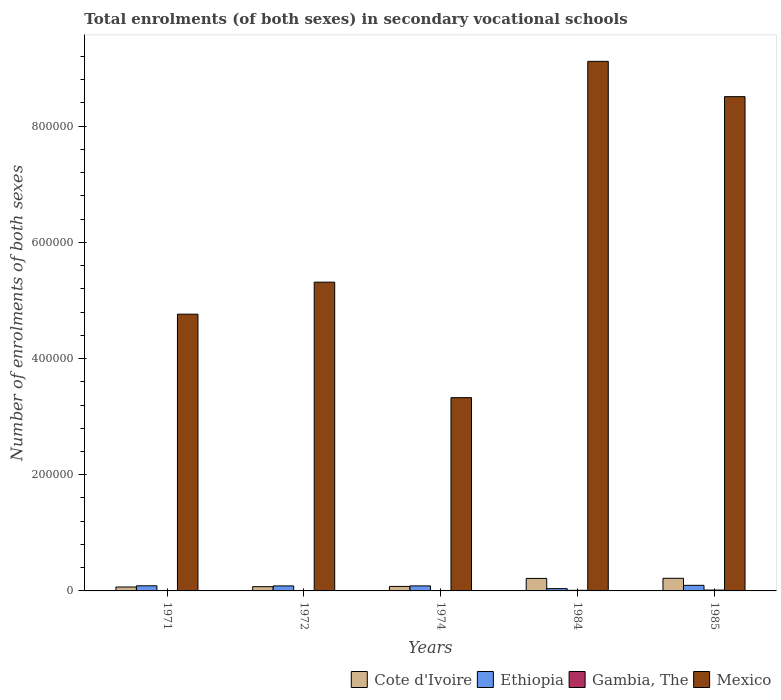Are the number of bars per tick equal to the number of legend labels?
Your answer should be very brief. Yes. Are the number of bars on each tick of the X-axis equal?
Ensure brevity in your answer.  Yes. How many bars are there on the 4th tick from the right?
Offer a terse response. 4. What is the label of the 1st group of bars from the left?
Offer a very short reply. 1971. In how many cases, is the number of bars for a given year not equal to the number of legend labels?
Make the answer very short. 0. What is the number of enrolments in secondary schools in Cote d'Ivoire in 1972?
Keep it short and to the point. 7297. Across all years, what is the maximum number of enrolments in secondary schools in Ethiopia?
Provide a succinct answer. 9618. Across all years, what is the minimum number of enrolments in secondary schools in Gambia, The?
Your answer should be compact. 330. In which year was the number of enrolments in secondary schools in Cote d'Ivoire minimum?
Offer a terse response. 1971. What is the total number of enrolments in secondary schools in Ethiopia in the graph?
Keep it short and to the point. 3.97e+04. What is the difference between the number of enrolments in secondary schools in Mexico in 1971 and that in 1974?
Ensure brevity in your answer.  1.44e+05. What is the difference between the number of enrolments in secondary schools in Mexico in 1985 and the number of enrolments in secondary schools in Cote d'Ivoire in 1984?
Offer a terse response. 8.29e+05. What is the average number of enrolments in secondary schools in Cote d'Ivoire per year?
Offer a very short reply. 1.30e+04. In the year 1974, what is the difference between the number of enrolments in secondary schools in Gambia, The and number of enrolments in secondary schools in Ethiopia?
Keep it short and to the point. -8276. What is the ratio of the number of enrolments in secondary schools in Ethiopia in 1974 to that in 1985?
Provide a succinct answer. 0.9. Is the difference between the number of enrolments in secondary schools in Gambia, The in 1971 and 1985 greater than the difference between the number of enrolments in secondary schools in Ethiopia in 1971 and 1985?
Ensure brevity in your answer.  No. What is the difference between the highest and the second highest number of enrolments in secondary schools in Ethiopia?
Your response must be concise. 796. What is the difference between the highest and the lowest number of enrolments in secondary schools in Gambia, The?
Ensure brevity in your answer.  1130. In how many years, is the number of enrolments in secondary schools in Ethiopia greater than the average number of enrolments in secondary schools in Ethiopia taken over all years?
Offer a terse response. 4. Is the sum of the number of enrolments in secondary schools in Ethiopia in 1984 and 1985 greater than the maximum number of enrolments in secondary schools in Gambia, The across all years?
Make the answer very short. Yes. What does the 2nd bar from the left in 1985 represents?
Your answer should be compact. Ethiopia. What does the 3rd bar from the right in 1974 represents?
Your response must be concise. Ethiopia. Is it the case that in every year, the sum of the number of enrolments in secondary schools in Gambia, The and number of enrolments in secondary schools in Ethiopia is greater than the number of enrolments in secondary schools in Mexico?
Ensure brevity in your answer.  No. Are all the bars in the graph horizontal?
Offer a very short reply. No. How many years are there in the graph?
Give a very brief answer. 5. How many legend labels are there?
Make the answer very short. 4. How are the legend labels stacked?
Ensure brevity in your answer.  Horizontal. What is the title of the graph?
Offer a terse response. Total enrolments (of both sexes) in secondary vocational schools. What is the label or title of the X-axis?
Provide a succinct answer. Years. What is the label or title of the Y-axis?
Keep it short and to the point. Number of enrolments of both sexes. What is the Number of enrolments of both sexes of Cote d'Ivoire in 1971?
Give a very brief answer. 6745. What is the Number of enrolments of both sexes in Ethiopia in 1971?
Your answer should be very brief. 8822. What is the Number of enrolments of both sexes in Gambia, The in 1971?
Provide a short and direct response. 330. What is the Number of enrolments of both sexes in Mexico in 1971?
Provide a succinct answer. 4.76e+05. What is the Number of enrolments of both sexes of Cote d'Ivoire in 1972?
Your answer should be compact. 7297. What is the Number of enrolments of both sexes of Ethiopia in 1972?
Provide a succinct answer. 8612. What is the Number of enrolments of both sexes in Gambia, The in 1972?
Ensure brevity in your answer.  376. What is the Number of enrolments of both sexes in Mexico in 1972?
Give a very brief answer. 5.32e+05. What is the Number of enrolments of both sexes in Cote d'Ivoire in 1974?
Make the answer very short. 7729. What is the Number of enrolments of both sexes in Ethiopia in 1974?
Your response must be concise. 8659. What is the Number of enrolments of both sexes of Gambia, The in 1974?
Keep it short and to the point. 383. What is the Number of enrolments of both sexes in Mexico in 1974?
Give a very brief answer. 3.33e+05. What is the Number of enrolments of both sexes in Cote d'Ivoire in 1984?
Your answer should be compact. 2.15e+04. What is the Number of enrolments of both sexes in Ethiopia in 1984?
Make the answer very short. 3949. What is the Number of enrolments of both sexes of Gambia, The in 1984?
Make the answer very short. 1040. What is the Number of enrolments of both sexes in Mexico in 1984?
Keep it short and to the point. 9.12e+05. What is the Number of enrolments of both sexes in Cote d'Ivoire in 1985?
Make the answer very short. 2.18e+04. What is the Number of enrolments of both sexes in Ethiopia in 1985?
Give a very brief answer. 9618. What is the Number of enrolments of both sexes of Gambia, The in 1985?
Give a very brief answer. 1460. What is the Number of enrolments of both sexes in Mexico in 1985?
Your answer should be compact. 8.51e+05. Across all years, what is the maximum Number of enrolments of both sexes of Cote d'Ivoire?
Provide a succinct answer. 2.18e+04. Across all years, what is the maximum Number of enrolments of both sexes of Ethiopia?
Make the answer very short. 9618. Across all years, what is the maximum Number of enrolments of both sexes of Gambia, The?
Your answer should be very brief. 1460. Across all years, what is the maximum Number of enrolments of both sexes of Mexico?
Provide a succinct answer. 9.12e+05. Across all years, what is the minimum Number of enrolments of both sexes in Cote d'Ivoire?
Your response must be concise. 6745. Across all years, what is the minimum Number of enrolments of both sexes in Ethiopia?
Your answer should be very brief. 3949. Across all years, what is the minimum Number of enrolments of both sexes of Gambia, The?
Offer a very short reply. 330. Across all years, what is the minimum Number of enrolments of both sexes of Mexico?
Ensure brevity in your answer.  3.33e+05. What is the total Number of enrolments of both sexes of Cote d'Ivoire in the graph?
Your response must be concise. 6.51e+04. What is the total Number of enrolments of both sexes of Ethiopia in the graph?
Your answer should be very brief. 3.97e+04. What is the total Number of enrolments of both sexes of Gambia, The in the graph?
Give a very brief answer. 3589. What is the total Number of enrolments of both sexes of Mexico in the graph?
Your answer should be very brief. 3.10e+06. What is the difference between the Number of enrolments of both sexes in Cote d'Ivoire in 1971 and that in 1972?
Offer a very short reply. -552. What is the difference between the Number of enrolments of both sexes of Ethiopia in 1971 and that in 1972?
Offer a terse response. 210. What is the difference between the Number of enrolments of both sexes of Gambia, The in 1971 and that in 1972?
Your answer should be compact. -46. What is the difference between the Number of enrolments of both sexes in Mexico in 1971 and that in 1972?
Offer a terse response. -5.51e+04. What is the difference between the Number of enrolments of both sexes of Cote d'Ivoire in 1971 and that in 1974?
Offer a terse response. -984. What is the difference between the Number of enrolments of both sexes of Ethiopia in 1971 and that in 1974?
Keep it short and to the point. 163. What is the difference between the Number of enrolments of both sexes of Gambia, The in 1971 and that in 1974?
Provide a short and direct response. -53. What is the difference between the Number of enrolments of both sexes in Mexico in 1971 and that in 1974?
Keep it short and to the point. 1.44e+05. What is the difference between the Number of enrolments of both sexes of Cote d'Ivoire in 1971 and that in 1984?
Provide a short and direct response. -1.48e+04. What is the difference between the Number of enrolments of both sexes in Ethiopia in 1971 and that in 1984?
Provide a short and direct response. 4873. What is the difference between the Number of enrolments of both sexes in Gambia, The in 1971 and that in 1984?
Your answer should be compact. -710. What is the difference between the Number of enrolments of both sexes of Mexico in 1971 and that in 1984?
Provide a short and direct response. -4.35e+05. What is the difference between the Number of enrolments of both sexes in Cote d'Ivoire in 1971 and that in 1985?
Your response must be concise. -1.50e+04. What is the difference between the Number of enrolments of both sexes in Ethiopia in 1971 and that in 1985?
Offer a terse response. -796. What is the difference between the Number of enrolments of both sexes of Gambia, The in 1971 and that in 1985?
Provide a succinct answer. -1130. What is the difference between the Number of enrolments of both sexes of Mexico in 1971 and that in 1985?
Give a very brief answer. -3.74e+05. What is the difference between the Number of enrolments of both sexes in Cote d'Ivoire in 1972 and that in 1974?
Provide a succinct answer. -432. What is the difference between the Number of enrolments of both sexes in Ethiopia in 1972 and that in 1974?
Offer a terse response. -47. What is the difference between the Number of enrolments of both sexes of Mexico in 1972 and that in 1974?
Offer a very short reply. 1.99e+05. What is the difference between the Number of enrolments of both sexes in Cote d'Ivoire in 1972 and that in 1984?
Provide a short and direct response. -1.42e+04. What is the difference between the Number of enrolments of both sexes of Ethiopia in 1972 and that in 1984?
Ensure brevity in your answer.  4663. What is the difference between the Number of enrolments of both sexes of Gambia, The in 1972 and that in 1984?
Offer a very short reply. -664. What is the difference between the Number of enrolments of both sexes of Mexico in 1972 and that in 1984?
Keep it short and to the point. -3.80e+05. What is the difference between the Number of enrolments of both sexes in Cote d'Ivoire in 1972 and that in 1985?
Offer a terse response. -1.45e+04. What is the difference between the Number of enrolments of both sexes of Ethiopia in 1972 and that in 1985?
Keep it short and to the point. -1006. What is the difference between the Number of enrolments of both sexes in Gambia, The in 1972 and that in 1985?
Offer a terse response. -1084. What is the difference between the Number of enrolments of both sexes in Mexico in 1972 and that in 1985?
Ensure brevity in your answer.  -3.19e+05. What is the difference between the Number of enrolments of both sexes of Cote d'Ivoire in 1974 and that in 1984?
Offer a terse response. -1.38e+04. What is the difference between the Number of enrolments of both sexes in Ethiopia in 1974 and that in 1984?
Your answer should be compact. 4710. What is the difference between the Number of enrolments of both sexes of Gambia, The in 1974 and that in 1984?
Provide a succinct answer. -657. What is the difference between the Number of enrolments of both sexes in Mexico in 1974 and that in 1984?
Ensure brevity in your answer.  -5.79e+05. What is the difference between the Number of enrolments of both sexes of Cote d'Ivoire in 1974 and that in 1985?
Provide a short and direct response. -1.40e+04. What is the difference between the Number of enrolments of both sexes of Ethiopia in 1974 and that in 1985?
Ensure brevity in your answer.  -959. What is the difference between the Number of enrolments of both sexes in Gambia, The in 1974 and that in 1985?
Offer a very short reply. -1077. What is the difference between the Number of enrolments of both sexes in Mexico in 1974 and that in 1985?
Keep it short and to the point. -5.18e+05. What is the difference between the Number of enrolments of both sexes of Cote d'Ivoire in 1984 and that in 1985?
Give a very brief answer. -213. What is the difference between the Number of enrolments of both sexes of Ethiopia in 1984 and that in 1985?
Provide a short and direct response. -5669. What is the difference between the Number of enrolments of both sexes of Gambia, The in 1984 and that in 1985?
Provide a succinct answer. -420. What is the difference between the Number of enrolments of both sexes in Mexico in 1984 and that in 1985?
Provide a succinct answer. 6.08e+04. What is the difference between the Number of enrolments of both sexes of Cote d'Ivoire in 1971 and the Number of enrolments of both sexes of Ethiopia in 1972?
Provide a short and direct response. -1867. What is the difference between the Number of enrolments of both sexes in Cote d'Ivoire in 1971 and the Number of enrolments of both sexes in Gambia, The in 1972?
Your response must be concise. 6369. What is the difference between the Number of enrolments of both sexes in Cote d'Ivoire in 1971 and the Number of enrolments of both sexes in Mexico in 1972?
Offer a very short reply. -5.25e+05. What is the difference between the Number of enrolments of both sexes in Ethiopia in 1971 and the Number of enrolments of both sexes in Gambia, The in 1972?
Offer a terse response. 8446. What is the difference between the Number of enrolments of both sexes in Ethiopia in 1971 and the Number of enrolments of both sexes in Mexico in 1972?
Make the answer very short. -5.23e+05. What is the difference between the Number of enrolments of both sexes in Gambia, The in 1971 and the Number of enrolments of both sexes in Mexico in 1972?
Ensure brevity in your answer.  -5.31e+05. What is the difference between the Number of enrolments of both sexes in Cote d'Ivoire in 1971 and the Number of enrolments of both sexes in Ethiopia in 1974?
Offer a very short reply. -1914. What is the difference between the Number of enrolments of both sexes in Cote d'Ivoire in 1971 and the Number of enrolments of both sexes in Gambia, The in 1974?
Make the answer very short. 6362. What is the difference between the Number of enrolments of both sexes of Cote d'Ivoire in 1971 and the Number of enrolments of both sexes of Mexico in 1974?
Your response must be concise. -3.26e+05. What is the difference between the Number of enrolments of both sexes of Ethiopia in 1971 and the Number of enrolments of both sexes of Gambia, The in 1974?
Make the answer very short. 8439. What is the difference between the Number of enrolments of both sexes of Ethiopia in 1971 and the Number of enrolments of both sexes of Mexico in 1974?
Ensure brevity in your answer.  -3.24e+05. What is the difference between the Number of enrolments of both sexes in Gambia, The in 1971 and the Number of enrolments of both sexes in Mexico in 1974?
Provide a succinct answer. -3.32e+05. What is the difference between the Number of enrolments of both sexes of Cote d'Ivoire in 1971 and the Number of enrolments of both sexes of Ethiopia in 1984?
Provide a short and direct response. 2796. What is the difference between the Number of enrolments of both sexes of Cote d'Ivoire in 1971 and the Number of enrolments of both sexes of Gambia, The in 1984?
Offer a terse response. 5705. What is the difference between the Number of enrolments of both sexes in Cote d'Ivoire in 1971 and the Number of enrolments of both sexes in Mexico in 1984?
Offer a terse response. -9.05e+05. What is the difference between the Number of enrolments of both sexes in Ethiopia in 1971 and the Number of enrolments of both sexes in Gambia, The in 1984?
Ensure brevity in your answer.  7782. What is the difference between the Number of enrolments of both sexes of Ethiopia in 1971 and the Number of enrolments of both sexes of Mexico in 1984?
Give a very brief answer. -9.03e+05. What is the difference between the Number of enrolments of both sexes in Gambia, The in 1971 and the Number of enrolments of both sexes in Mexico in 1984?
Give a very brief answer. -9.11e+05. What is the difference between the Number of enrolments of both sexes of Cote d'Ivoire in 1971 and the Number of enrolments of both sexes of Ethiopia in 1985?
Your response must be concise. -2873. What is the difference between the Number of enrolments of both sexes of Cote d'Ivoire in 1971 and the Number of enrolments of both sexes of Gambia, The in 1985?
Make the answer very short. 5285. What is the difference between the Number of enrolments of both sexes in Cote d'Ivoire in 1971 and the Number of enrolments of both sexes in Mexico in 1985?
Keep it short and to the point. -8.44e+05. What is the difference between the Number of enrolments of both sexes of Ethiopia in 1971 and the Number of enrolments of both sexes of Gambia, The in 1985?
Your answer should be very brief. 7362. What is the difference between the Number of enrolments of both sexes of Ethiopia in 1971 and the Number of enrolments of both sexes of Mexico in 1985?
Provide a short and direct response. -8.42e+05. What is the difference between the Number of enrolments of both sexes in Gambia, The in 1971 and the Number of enrolments of both sexes in Mexico in 1985?
Offer a very short reply. -8.51e+05. What is the difference between the Number of enrolments of both sexes of Cote d'Ivoire in 1972 and the Number of enrolments of both sexes of Ethiopia in 1974?
Keep it short and to the point. -1362. What is the difference between the Number of enrolments of both sexes in Cote d'Ivoire in 1972 and the Number of enrolments of both sexes in Gambia, The in 1974?
Keep it short and to the point. 6914. What is the difference between the Number of enrolments of both sexes in Cote d'Ivoire in 1972 and the Number of enrolments of both sexes in Mexico in 1974?
Offer a terse response. -3.25e+05. What is the difference between the Number of enrolments of both sexes of Ethiopia in 1972 and the Number of enrolments of both sexes of Gambia, The in 1974?
Provide a short and direct response. 8229. What is the difference between the Number of enrolments of both sexes of Ethiopia in 1972 and the Number of enrolments of both sexes of Mexico in 1974?
Your answer should be compact. -3.24e+05. What is the difference between the Number of enrolments of both sexes of Gambia, The in 1972 and the Number of enrolments of both sexes of Mexico in 1974?
Offer a very short reply. -3.32e+05. What is the difference between the Number of enrolments of both sexes in Cote d'Ivoire in 1972 and the Number of enrolments of both sexes in Ethiopia in 1984?
Offer a very short reply. 3348. What is the difference between the Number of enrolments of both sexes of Cote d'Ivoire in 1972 and the Number of enrolments of both sexes of Gambia, The in 1984?
Provide a succinct answer. 6257. What is the difference between the Number of enrolments of both sexes of Cote d'Ivoire in 1972 and the Number of enrolments of both sexes of Mexico in 1984?
Your response must be concise. -9.04e+05. What is the difference between the Number of enrolments of both sexes of Ethiopia in 1972 and the Number of enrolments of both sexes of Gambia, The in 1984?
Ensure brevity in your answer.  7572. What is the difference between the Number of enrolments of both sexes in Ethiopia in 1972 and the Number of enrolments of both sexes in Mexico in 1984?
Offer a very short reply. -9.03e+05. What is the difference between the Number of enrolments of both sexes of Gambia, The in 1972 and the Number of enrolments of both sexes of Mexico in 1984?
Make the answer very short. -9.11e+05. What is the difference between the Number of enrolments of both sexes of Cote d'Ivoire in 1972 and the Number of enrolments of both sexes of Ethiopia in 1985?
Your answer should be compact. -2321. What is the difference between the Number of enrolments of both sexes of Cote d'Ivoire in 1972 and the Number of enrolments of both sexes of Gambia, The in 1985?
Your response must be concise. 5837. What is the difference between the Number of enrolments of both sexes of Cote d'Ivoire in 1972 and the Number of enrolments of both sexes of Mexico in 1985?
Keep it short and to the point. -8.44e+05. What is the difference between the Number of enrolments of both sexes of Ethiopia in 1972 and the Number of enrolments of both sexes of Gambia, The in 1985?
Your answer should be very brief. 7152. What is the difference between the Number of enrolments of both sexes of Ethiopia in 1972 and the Number of enrolments of both sexes of Mexico in 1985?
Your answer should be compact. -8.42e+05. What is the difference between the Number of enrolments of both sexes of Gambia, The in 1972 and the Number of enrolments of both sexes of Mexico in 1985?
Offer a terse response. -8.51e+05. What is the difference between the Number of enrolments of both sexes in Cote d'Ivoire in 1974 and the Number of enrolments of both sexes in Ethiopia in 1984?
Your answer should be compact. 3780. What is the difference between the Number of enrolments of both sexes of Cote d'Ivoire in 1974 and the Number of enrolments of both sexes of Gambia, The in 1984?
Your answer should be very brief. 6689. What is the difference between the Number of enrolments of both sexes of Cote d'Ivoire in 1974 and the Number of enrolments of both sexes of Mexico in 1984?
Your answer should be very brief. -9.04e+05. What is the difference between the Number of enrolments of both sexes of Ethiopia in 1974 and the Number of enrolments of both sexes of Gambia, The in 1984?
Give a very brief answer. 7619. What is the difference between the Number of enrolments of both sexes in Ethiopia in 1974 and the Number of enrolments of both sexes in Mexico in 1984?
Your response must be concise. -9.03e+05. What is the difference between the Number of enrolments of both sexes in Gambia, The in 1974 and the Number of enrolments of both sexes in Mexico in 1984?
Provide a short and direct response. -9.11e+05. What is the difference between the Number of enrolments of both sexes of Cote d'Ivoire in 1974 and the Number of enrolments of both sexes of Ethiopia in 1985?
Provide a succinct answer. -1889. What is the difference between the Number of enrolments of both sexes in Cote d'Ivoire in 1974 and the Number of enrolments of both sexes in Gambia, The in 1985?
Provide a succinct answer. 6269. What is the difference between the Number of enrolments of both sexes in Cote d'Ivoire in 1974 and the Number of enrolments of both sexes in Mexico in 1985?
Provide a succinct answer. -8.43e+05. What is the difference between the Number of enrolments of both sexes in Ethiopia in 1974 and the Number of enrolments of both sexes in Gambia, The in 1985?
Provide a short and direct response. 7199. What is the difference between the Number of enrolments of both sexes in Ethiopia in 1974 and the Number of enrolments of both sexes in Mexico in 1985?
Give a very brief answer. -8.42e+05. What is the difference between the Number of enrolments of both sexes of Gambia, The in 1974 and the Number of enrolments of both sexes of Mexico in 1985?
Your answer should be compact. -8.51e+05. What is the difference between the Number of enrolments of both sexes of Cote d'Ivoire in 1984 and the Number of enrolments of both sexes of Ethiopia in 1985?
Your answer should be compact. 1.19e+04. What is the difference between the Number of enrolments of both sexes in Cote d'Ivoire in 1984 and the Number of enrolments of both sexes in Gambia, The in 1985?
Offer a very short reply. 2.01e+04. What is the difference between the Number of enrolments of both sexes in Cote d'Ivoire in 1984 and the Number of enrolments of both sexes in Mexico in 1985?
Make the answer very short. -8.29e+05. What is the difference between the Number of enrolments of both sexes in Ethiopia in 1984 and the Number of enrolments of both sexes in Gambia, The in 1985?
Offer a very short reply. 2489. What is the difference between the Number of enrolments of both sexes of Ethiopia in 1984 and the Number of enrolments of both sexes of Mexico in 1985?
Your response must be concise. -8.47e+05. What is the difference between the Number of enrolments of both sexes of Gambia, The in 1984 and the Number of enrolments of both sexes of Mexico in 1985?
Make the answer very short. -8.50e+05. What is the average Number of enrolments of both sexes in Cote d'Ivoire per year?
Offer a very short reply. 1.30e+04. What is the average Number of enrolments of both sexes in Ethiopia per year?
Your answer should be very brief. 7932. What is the average Number of enrolments of both sexes of Gambia, The per year?
Offer a terse response. 717.8. What is the average Number of enrolments of both sexes in Mexico per year?
Ensure brevity in your answer.  6.21e+05. In the year 1971, what is the difference between the Number of enrolments of both sexes of Cote d'Ivoire and Number of enrolments of both sexes of Ethiopia?
Ensure brevity in your answer.  -2077. In the year 1971, what is the difference between the Number of enrolments of both sexes in Cote d'Ivoire and Number of enrolments of both sexes in Gambia, The?
Provide a succinct answer. 6415. In the year 1971, what is the difference between the Number of enrolments of both sexes of Cote d'Ivoire and Number of enrolments of both sexes of Mexico?
Offer a terse response. -4.70e+05. In the year 1971, what is the difference between the Number of enrolments of both sexes in Ethiopia and Number of enrolments of both sexes in Gambia, The?
Keep it short and to the point. 8492. In the year 1971, what is the difference between the Number of enrolments of both sexes in Ethiopia and Number of enrolments of both sexes in Mexico?
Ensure brevity in your answer.  -4.68e+05. In the year 1971, what is the difference between the Number of enrolments of both sexes of Gambia, The and Number of enrolments of both sexes of Mexico?
Keep it short and to the point. -4.76e+05. In the year 1972, what is the difference between the Number of enrolments of both sexes in Cote d'Ivoire and Number of enrolments of both sexes in Ethiopia?
Offer a terse response. -1315. In the year 1972, what is the difference between the Number of enrolments of both sexes in Cote d'Ivoire and Number of enrolments of both sexes in Gambia, The?
Your answer should be compact. 6921. In the year 1972, what is the difference between the Number of enrolments of both sexes of Cote d'Ivoire and Number of enrolments of both sexes of Mexico?
Offer a very short reply. -5.24e+05. In the year 1972, what is the difference between the Number of enrolments of both sexes of Ethiopia and Number of enrolments of both sexes of Gambia, The?
Keep it short and to the point. 8236. In the year 1972, what is the difference between the Number of enrolments of both sexes of Ethiopia and Number of enrolments of both sexes of Mexico?
Offer a terse response. -5.23e+05. In the year 1972, what is the difference between the Number of enrolments of both sexes in Gambia, The and Number of enrolments of both sexes in Mexico?
Offer a terse response. -5.31e+05. In the year 1974, what is the difference between the Number of enrolments of both sexes in Cote d'Ivoire and Number of enrolments of both sexes in Ethiopia?
Your answer should be compact. -930. In the year 1974, what is the difference between the Number of enrolments of both sexes of Cote d'Ivoire and Number of enrolments of both sexes of Gambia, The?
Your response must be concise. 7346. In the year 1974, what is the difference between the Number of enrolments of both sexes of Cote d'Ivoire and Number of enrolments of both sexes of Mexico?
Offer a terse response. -3.25e+05. In the year 1974, what is the difference between the Number of enrolments of both sexes of Ethiopia and Number of enrolments of both sexes of Gambia, The?
Give a very brief answer. 8276. In the year 1974, what is the difference between the Number of enrolments of both sexes in Ethiopia and Number of enrolments of both sexes in Mexico?
Keep it short and to the point. -3.24e+05. In the year 1974, what is the difference between the Number of enrolments of both sexes in Gambia, The and Number of enrolments of both sexes in Mexico?
Ensure brevity in your answer.  -3.32e+05. In the year 1984, what is the difference between the Number of enrolments of both sexes in Cote d'Ivoire and Number of enrolments of both sexes in Ethiopia?
Your response must be concise. 1.76e+04. In the year 1984, what is the difference between the Number of enrolments of both sexes of Cote d'Ivoire and Number of enrolments of both sexes of Gambia, The?
Offer a very short reply. 2.05e+04. In the year 1984, what is the difference between the Number of enrolments of both sexes in Cote d'Ivoire and Number of enrolments of both sexes in Mexico?
Provide a succinct answer. -8.90e+05. In the year 1984, what is the difference between the Number of enrolments of both sexes in Ethiopia and Number of enrolments of both sexes in Gambia, The?
Provide a succinct answer. 2909. In the year 1984, what is the difference between the Number of enrolments of both sexes in Ethiopia and Number of enrolments of both sexes in Mexico?
Ensure brevity in your answer.  -9.08e+05. In the year 1984, what is the difference between the Number of enrolments of both sexes of Gambia, The and Number of enrolments of both sexes of Mexico?
Offer a terse response. -9.11e+05. In the year 1985, what is the difference between the Number of enrolments of both sexes of Cote d'Ivoire and Number of enrolments of both sexes of Ethiopia?
Your response must be concise. 1.21e+04. In the year 1985, what is the difference between the Number of enrolments of both sexes in Cote d'Ivoire and Number of enrolments of both sexes in Gambia, The?
Keep it short and to the point. 2.03e+04. In the year 1985, what is the difference between the Number of enrolments of both sexes in Cote d'Ivoire and Number of enrolments of both sexes in Mexico?
Ensure brevity in your answer.  -8.29e+05. In the year 1985, what is the difference between the Number of enrolments of both sexes of Ethiopia and Number of enrolments of both sexes of Gambia, The?
Your answer should be compact. 8158. In the year 1985, what is the difference between the Number of enrolments of both sexes of Ethiopia and Number of enrolments of both sexes of Mexico?
Your response must be concise. -8.41e+05. In the year 1985, what is the difference between the Number of enrolments of both sexes in Gambia, The and Number of enrolments of both sexes in Mexico?
Your answer should be compact. -8.49e+05. What is the ratio of the Number of enrolments of both sexes of Cote d'Ivoire in 1971 to that in 1972?
Your answer should be compact. 0.92. What is the ratio of the Number of enrolments of both sexes of Ethiopia in 1971 to that in 1972?
Ensure brevity in your answer.  1.02. What is the ratio of the Number of enrolments of both sexes in Gambia, The in 1971 to that in 1972?
Keep it short and to the point. 0.88. What is the ratio of the Number of enrolments of both sexes of Mexico in 1971 to that in 1972?
Provide a succinct answer. 0.9. What is the ratio of the Number of enrolments of both sexes in Cote d'Ivoire in 1971 to that in 1974?
Your response must be concise. 0.87. What is the ratio of the Number of enrolments of both sexes in Ethiopia in 1971 to that in 1974?
Provide a succinct answer. 1.02. What is the ratio of the Number of enrolments of both sexes of Gambia, The in 1971 to that in 1974?
Offer a very short reply. 0.86. What is the ratio of the Number of enrolments of both sexes of Mexico in 1971 to that in 1974?
Keep it short and to the point. 1.43. What is the ratio of the Number of enrolments of both sexes of Cote d'Ivoire in 1971 to that in 1984?
Provide a succinct answer. 0.31. What is the ratio of the Number of enrolments of both sexes of Ethiopia in 1971 to that in 1984?
Your answer should be compact. 2.23. What is the ratio of the Number of enrolments of both sexes in Gambia, The in 1971 to that in 1984?
Your response must be concise. 0.32. What is the ratio of the Number of enrolments of both sexes of Mexico in 1971 to that in 1984?
Make the answer very short. 0.52. What is the ratio of the Number of enrolments of both sexes in Cote d'Ivoire in 1971 to that in 1985?
Offer a very short reply. 0.31. What is the ratio of the Number of enrolments of both sexes of Ethiopia in 1971 to that in 1985?
Make the answer very short. 0.92. What is the ratio of the Number of enrolments of both sexes of Gambia, The in 1971 to that in 1985?
Make the answer very short. 0.23. What is the ratio of the Number of enrolments of both sexes in Mexico in 1971 to that in 1985?
Your answer should be compact. 0.56. What is the ratio of the Number of enrolments of both sexes in Cote d'Ivoire in 1972 to that in 1974?
Ensure brevity in your answer.  0.94. What is the ratio of the Number of enrolments of both sexes of Gambia, The in 1972 to that in 1974?
Your answer should be compact. 0.98. What is the ratio of the Number of enrolments of both sexes in Mexico in 1972 to that in 1974?
Ensure brevity in your answer.  1.6. What is the ratio of the Number of enrolments of both sexes of Cote d'Ivoire in 1972 to that in 1984?
Offer a terse response. 0.34. What is the ratio of the Number of enrolments of both sexes of Ethiopia in 1972 to that in 1984?
Make the answer very short. 2.18. What is the ratio of the Number of enrolments of both sexes in Gambia, The in 1972 to that in 1984?
Provide a short and direct response. 0.36. What is the ratio of the Number of enrolments of both sexes in Mexico in 1972 to that in 1984?
Ensure brevity in your answer.  0.58. What is the ratio of the Number of enrolments of both sexes of Cote d'Ivoire in 1972 to that in 1985?
Your answer should be compact. 0.34. What is the ratio of the Number of enrolments of both sexes of Ethiopia in 1972 to that in 1985?
Your answer should be compact. 0.9. What is the ratio of the Number of enrolments of both sexes of Gambia, The in 1972 to that in 1985?
Give a very brief answer. 0.26. What is the ratio of the Number of enrolments of both sexes of Mexico in 1972 to that in 1985?
Give a very brief answer. 0.62. What is the ratio of the Number of enrolments of both sexes in Cote d'Ivoire in 1974 to that in 1984?
Provide a short and direct response. 0.36. What is the ratio of the Number of enrolments of both sexes of Ethiopia in 1974 to that in 1984?
Keep it short and to the point. 2.19. What is the ratio of the Number of enrolments of both sexes of Gambia, The in 1974 to that in 1984?
Ensure brevity in your answer.  0.37. What is the ratio of the Number of enrolments of both sexes in Mexico in 1974 to that in 1984?
Offer a very short reply. 0.36. What is the ratio of the Number of enrolments of both sexes of Cote d'Ivoire in 1974 to that in 1985?
Provide a short and direct response. 0.36. What is the ratio of the Number of enrolments of both sexes of Ethiopia in 1974 to that in 1985?
Give a very brief answer. 0.9. What is the ratio of the Number of enrolments of both sexes of Gambia, The in 1974 to that in 1985?
Offer a very short reply. 0.26. What is the ratio of the Number of enrolments of both sexes of Mexico in 1974 to that in 1985?
Offer a terse response. 0.39. What is the ratio of the Number of enrolments of both sexes of Cote d'Ivoire in 1984 to that in 1985?
Offer a terse response. 0.99. What is the ratio of the Number of enrolments of both sexes in Ethiopia in 1984 to that in 1985?
Provide a succinct answer. 0.41. What is the ratio of the Number of enrolments of both sexes in Gambia, The in 1984 to that in 1985?
Provide a succinct answer. 0.71. What is the ratio of the Number of enrolments of both sexes of Mexico in 1984 to that in 1985?
Provide a succinct answer. 1.07. What is the difference between the highest and the second highest Number of enrolments of both sexes of Cote d'Ivoire?
Give a very brief answer. 213. What is the difference between the highest and the second highest Number of enrolments of both sexes of Ethiopia?
Your answer should be very brief. 796. What is the difference between the highest and the second highest Number of enrolments of both sexes in Gambia, The?
Your answer should be compact. 420. What is the difference between the highest and the second highest Number of enrolments of both sexes of Mexico?
Your answer should be very brief. 6.08e+04. What is the difference between the highest and the lowest Number of enrolments of both sexes of Cote d'Ivoire?
Provide a succinct answer. 1.50e+04. What is the difference between the highest and the lowest Number of enrolments of both sexes in Ethiopia?
Your answer should be compact. 5669. What is the difference between the highest and the lowest Number of enrolments of both sexes of Gambia, The?
Your response must be concise. 1130. What is the difference between the highest and the lowest Number of enrolments of both sexes of Mexico?
Provide a succinct answer. 5.79e+05. 